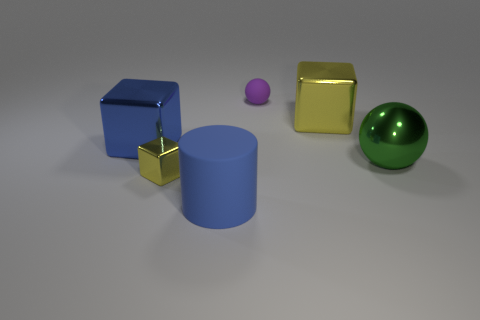What is the tiny thing behind the tiny yellow shiny cube made of?
Ensure brevity in your answer.  Rubber. Are there the same number of big matte cylinders in front of the large yellow metallic thing and yellow metallic cubes on the left side of the purple ball?
Keep it short and to the point. Yes. There is a tiny matte object that is the same shape as the green shiny thing; what is its color?
Provide a short and direct response. Purple. Is there any other thing that is the same color as the large matte cylinder?
Your answer should be very brief. Yes. How many shiny objects are either big yellow things or small balls?
Provide a succinct answer. 1. Is the number of cubes that are to the right of the large blue cube greater than the number of small yellow metal blocks?
Ensure brevity in your answer.  Yes. How many other things are made of the same material as the big cylinder?
Your answer should be compact. 1. How many big objects are either shiny blocks or green spheres?
Offer a very short reply. 3. Is the material of the green sphere the same as the small yellow cube?
Provide a succinct answer. Yes. How many tiny objects are behind the metallic cube that is left of the small yellow object?
Your response must be concise. 1. 